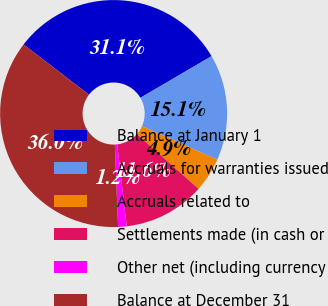Convert chart to OTSL. <chart><loc_0><loc_0><loc_500><loc_500><pie_chart><fcel>Balance at January 1<fcel>Accruals for warranties issued<fcel>Accruals related to<fcel>Settlements made (in cash or<fcel>Other net (including currency<fcel>Balance at December 31<nl><fcel>31.15%<fcel>15.09%<fcel>4.89%<fcel>11.61%<fcel>1.22%<fcel>36.04%<nl></chart> 